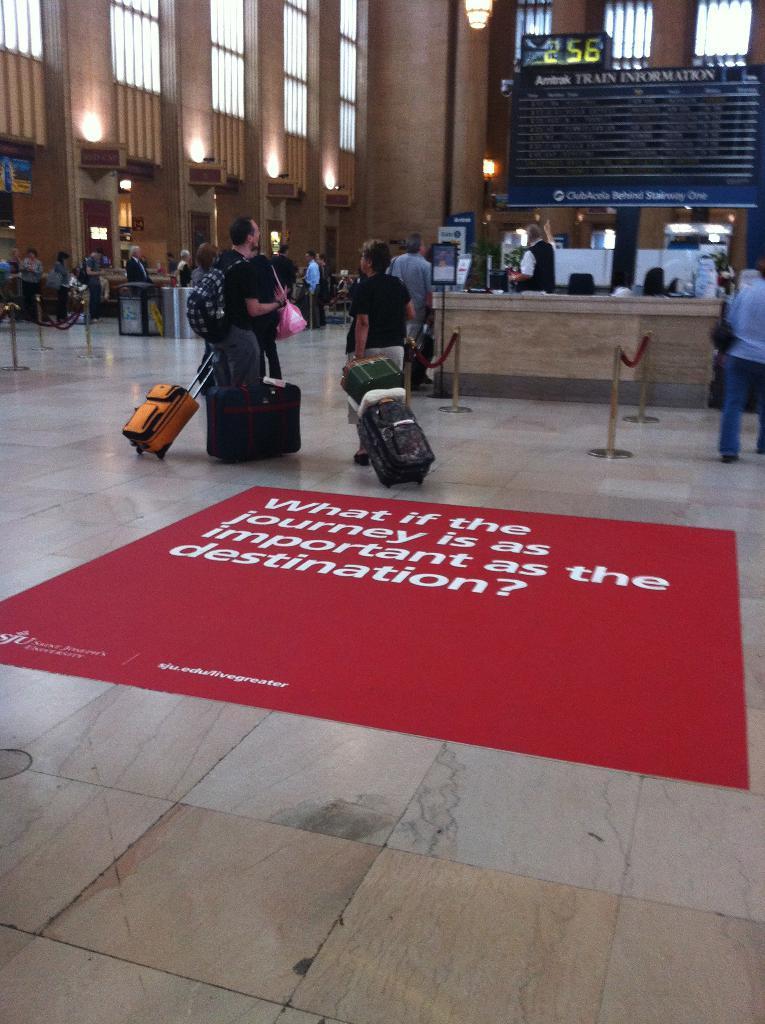Could you give a brief overview of what you see in this image? The picture is clicked in an airport where there are people with their luggages and there is a red color mat on top of which what if the journey is as important as destination. 